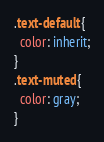<code> <loc_0><loc_0><loc_500><loc_500><_CSS_>.text-default {
  color: inherit;
}
.text-muted {
  color: gray;
}</code> 